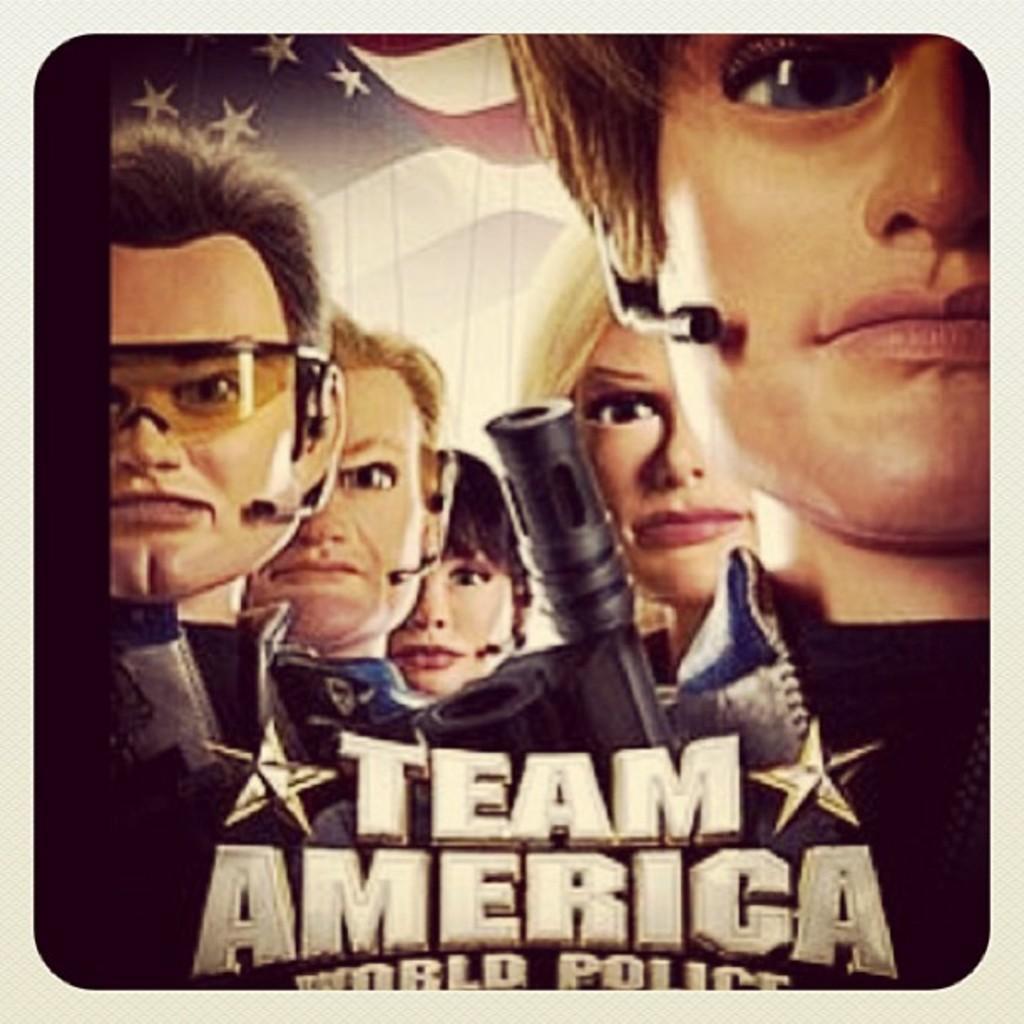Could you give a brief overview of what you see in this image? In this picture I can see the text at the bottom, in the middle there are animated humans, in the background there is the flag. 